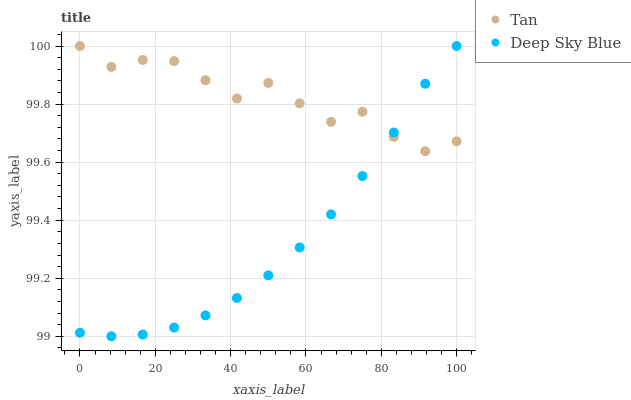Does Deep Sky Blue have the minimum area under the curve?
Answer yes or no. Yes. Does Tan have the maximum area under the curve?
Answer yes or no. Yes. Does Deep Sky Blue have the maximum area under the curve?
Answer yes or no. No. Is Deep Sky Blue the smoothest?
Answer yes or no. Yes. Is Tan the roughest?
Answer yes or no. Yes. Is Deep Sky Blue the roughest?
Answer yes or no. No. Does Deep Sky Blue have the lowest value?
Answer yes or no. Yes. Does Deep Sky Blue have the highest value?
Answer yes or no. Yes. Does Deep Sky Blue intersect Tan?
Answer yes or no. Yes. Is Deep Sky Blue less than Tan?
Answer yes or no. No. Is Deep Sky Blue greater than Tan?
Answer yes or no. No. 